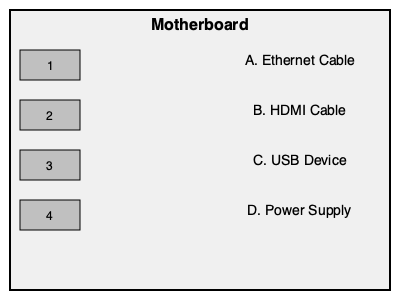Match the computer components (A-D) with their corresponding ports (1-4) on the motherboard diagram. To match the computer components with their corresponding ports, let's analyze each component and port:

1. USB Port: This is a rectangular port commonly used for connecting various devices such as keyboards, mice, and external drives. It corresponds to component C (USB Device).

2. HDMI Port: This port has a distinctive shape with one side slightly wider than the other. It's used for connecting displays and corresponds to component B (HDMI Cable).

3. Ethernet Port: This port is slightly larger than the USB port and has a shape that resembles a wide telephone jack. It's used for network connections and corresponds to component A (Ethernet Cable).

4. Power Connector: This is typically the largest connector on the motherboard, often rectangular or square-shaped. It provides power to the entire system and corresponds to component D (Power Supply).

By matching the characteristics of each port with the appropriate component, we can determine the correct pairings.
Answer: 1-C, 2-B, 3-A, 4-D 